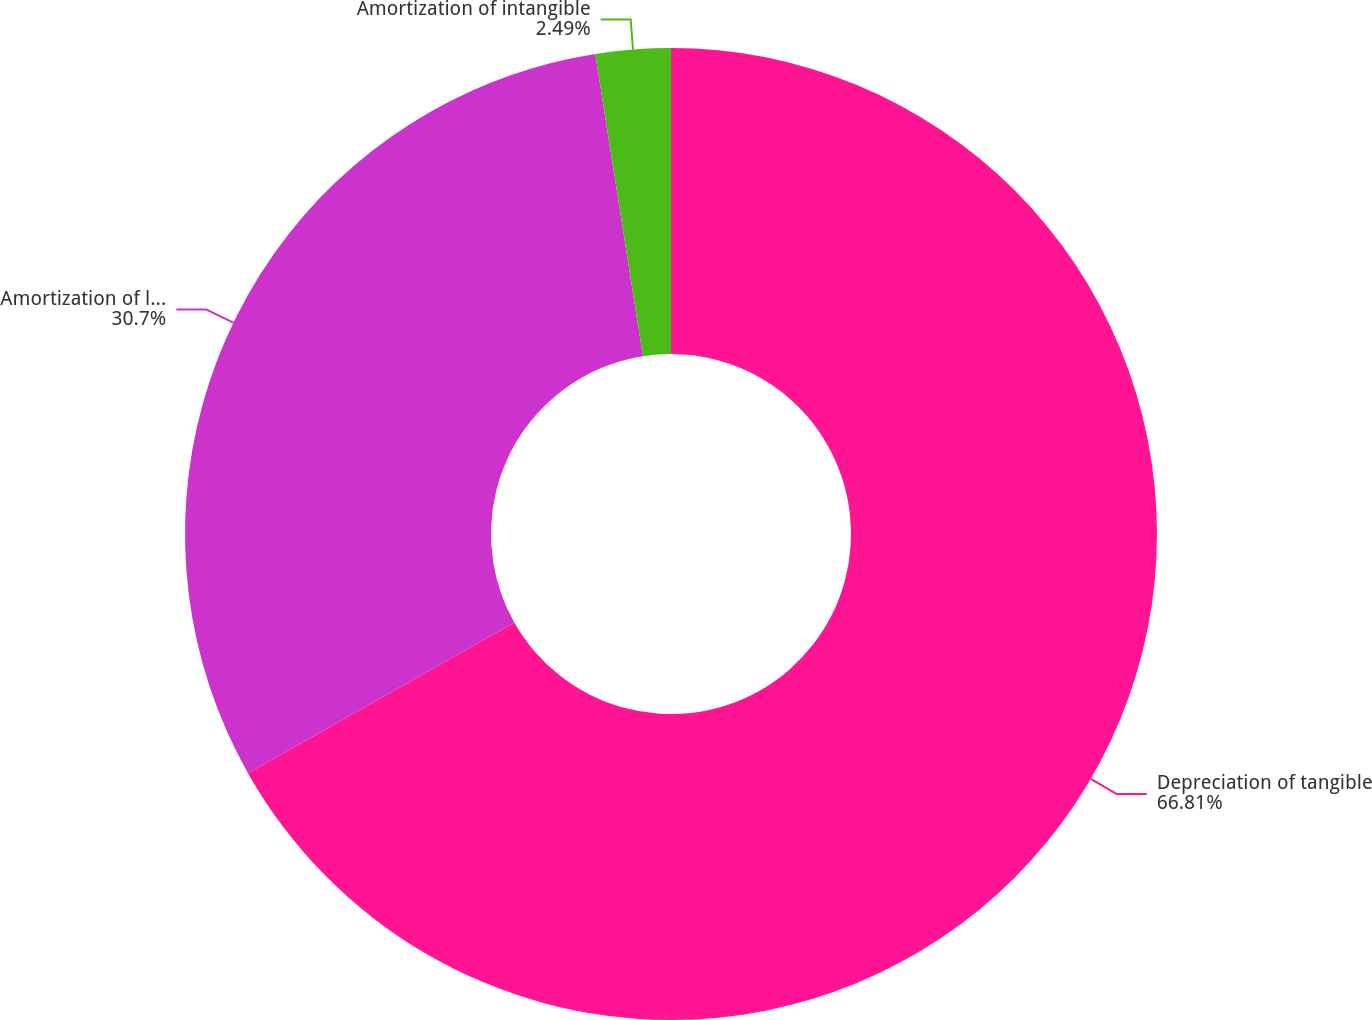Convert chart. <chart><loc_0><loc_0><loc_500><loc_500><pie_chart><fcel>Depreciation of tangible<fcel>Amortization of landfill<fcel>Amortization of intangible<nl><fcel>66.81%<fcel>30.7%<fcel>2.49%<nl></chart> 